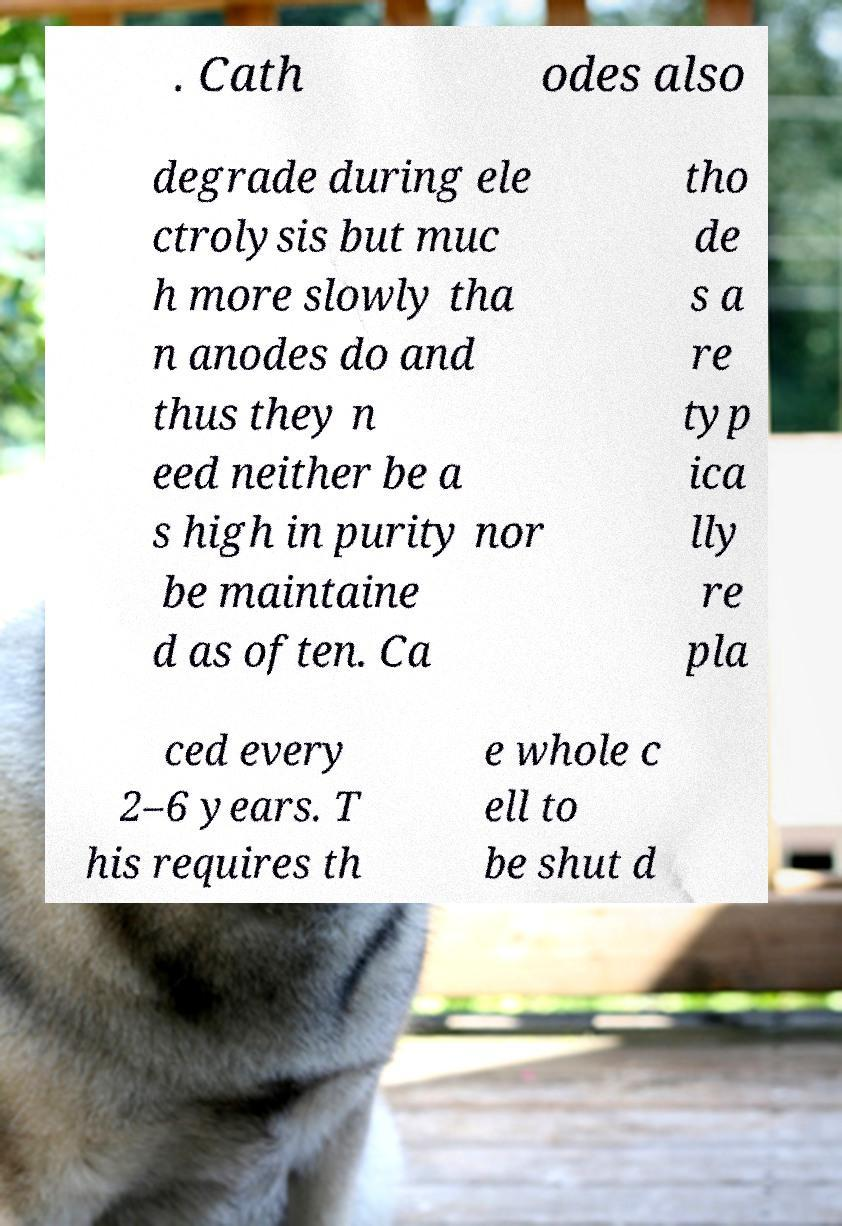Please read and relay the text visible in this image. What does it say? . Cath odes also degrade during ele ctrolysis but muc h more slowly tha n anodes do and thus they n eed neither be a s high in purity nor be maintaine d as often. Ca tho de s a re typ ica lly re pla ced every 2–6 years. T his requires th e whole c ell to be shut d 